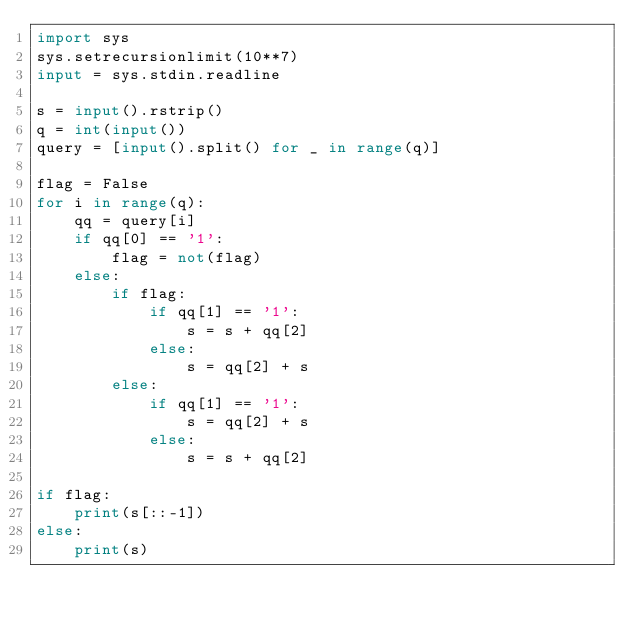Convert code to text. <code><loc_0><loc_0><loc_500><loc_500><_Python_>import sys
sys.setrecursionlimit(10**7)
input = sys.stdin.readline

s = input().rstrip()
q = int(input())
query = [input().split() for _ in range(q)]

flag = False
for i in range(q):
    qq = query[i]
    if qq[0] == '1':
        flag = not(flag)
    else:
        if flag:
            if qq[1] == '1':
                s = s + qq[2]
            else:
                s = qq[2] + s
        else:
            if qq[1] == '1':
                s = qq[2] + s
            else:
                s = s + qq[2]

if flag:
    print(s[::-1])
else:
    print(s)
</code> 